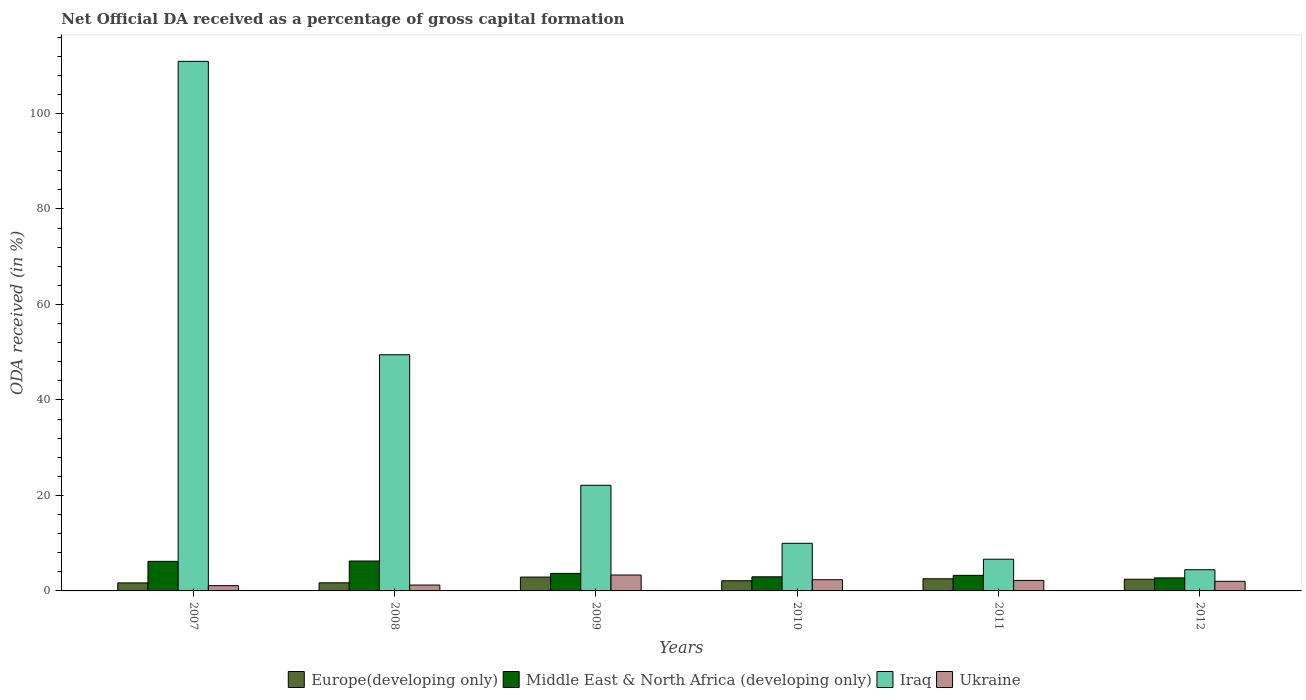How many groups of bars are there?
Provide a succinct answer. 6. Are the number of bars per tick equal to the number of legend labels?
Provide a short and direct response. Yes. Are the number of bars on each tick of the X-axis equal?
Give a very brief answer. Yes. How many bars are there on the 4th tick from the right?
Ensure brevity in your answer.  4. What is the net ODA received in Europe(developing only) in 2008?
Make the answer very short. 1.7. Across all years, what is the maximum net ODA received in Ukraine?
Ensure brevity in your answer.  3.33. Across all years, what is the minimum net ODA received in Ukraine?
Provide a short and direct response. 1.1. In which year was the net ODA received in Ukraine minimum?
Keep it short and to the point. 2007. What is the total net ODA received in Ukraine in the graph?
Your answer should be compact. 12.23. What is the difference between the net ODA received in Middle East & North Africa (developing only) in 2011 and that in 2012?
Your answer should be compact. 0.53. What is the difference between the net ODA received in Iraq in 2007 and the net ODA received in Europe(developing only) in 2009?
Offer a very short reply. 108.01. What is the average net ODA received in Iraq per year?
Offer a terse response. 33.92. In the year 2008, what is the difference between the net ODA received in Europe(developing only) and net ODA received in Iraq?
Your answer should be very brief. -47.76. In how many years, is the net ODA received in Ukraine greater than 112 %?
Provide a succinct answer. 0. What is the ratio of the net ODA received in Ukraine in 2007 to that in 2009?
Give a very brief answer. 0.33. Is the difference between the net ODA received in Europe(developing only) in 2008 and 2011 greater than the difference between the net ODA received in Iraq in 2008 and 2011?
Make the answer very short. No. What is the difference between the highest and the second highest net ODA received in Europe(developing only)?
Provide a succinct answer. 0.36. What is the difference between the highest and the lowest net ODA received in Iraq?
Offer a terse response. 106.47. Is it the case that in every year, the sum of the net ODA received in Middle East & North Africa (developing only) and net ODA received in Iraq is greater than the sum of net ODA received in Ukraine and net ODA received in Europe(developing only)?
Provide a short and direct response. No. What does the 2nd bar from the left in 2010 represents?
Give a very brief answer. Middle East & North Africa (developing only). What does the 2nd bar from the right in 2007 represents?
Your answer should be very brief. Iraq. How many bars are there?
Your answer should be compact. 24. Are all the bars in the graph horizontal?
Give a very brief answer. No. How many years are there in the graph?
Offer a very short reply. 6. Does the graph contain any zero values?
Make the answer very short. No. How many legend labels are there?
Ensure brevity in your answer.  4. What is the title of the graph?
Offer a terse response. Net Official DA received as a percentage of gross capital formation. What is the label or title of the X-axis?
Your answer should be compact. Years. What is the label or title of the Y-axis?
Offer a very short reply. ODA received (in %). What is the ODA received (in %) of Europe(developing only) in 2007?
Your answer should be very brief. 1.68. What is the ODA received (in %) of Middle East & North Africa (developing only) in 2007?
Provide a succinct answer. 6.2. What is the ODA received (in %) in Iraq in 2007?
Your response must be concise. 110.91. What is the ODA received (in %) in Ukraine in 2007?
Provide a short and direct response. 1.1. What is the ODA received (in %) of Europe(developing only) in 2008?
Your answer should be very brief. 1.7. What is the ODA received (in %) of Middle East & North Africa (developing only) in 2008?
Offer a very short reply. 6.26. What is the ODA received (in %) in Iraq in 2008?
Your answer should be compact. 49.46. What is the ODA received (in %) in Ukraine in 2008?
Your answer should be very brief. 1.23. What is the ODA received (in %) in Europe(developing only) in 2009?
Provide a short and direct response. 2.9. What is the ODA received (in %) of Middle East & North Africa (developing only) in 2009?
Keep it short and to the point. 3.67. What is the ODA received (in %) in Iraq in 2009?
Keep it short and to the point. 22.13. What is the ODA received (in %) of Ukraine in 2009?
Make the answer very short. 3.33. What is the ODA received (in %) in Europe(developing only) in 2010?
Keep it short and to the point. 2.13. What is the ODA received (in %) in Middle East & North Africa (developing only) in 2010?
Provide a succinct answer. 2.96. What is the ODA received (in %) of Iraq in 2010?
Offer a terse response. 9.97. What is the ODA received (in %) of Ukraine in 2010?
Your answer should be compact. 2.35. What is the ODA received (in %) of Europe(developing only) in 2011?
Ensure brevity in your answer.  2.54. What is the ODA received (in %) of Middle East & North Africa (developing only) in 2011?
Provide a succinct answer. 3.27. What is the ODA received (in %) in Iraq in 2011?
Offer a very short reply. 6.65. What is the ODA received (in %) of Ukraine in 2011?
Provide a short and direct response. 2.2. What is the ODA received (in %) of Europe(developing only) in 2012?
Your answer should be very brief. 2.45. What is the ODA received (in %) of Middle East & North Africa (developing only) in 2012?
Your answer should be very brief. 2.73. What is the ODA received (in %) in Iraq in 2012?
Offer a very short reply. 4.44. What is the ODA received (in %) in Ukraine in 2012?
Provide a succinct answer. 2.02. Across all years, what is the maximum ODA received (in %) in Europe(developing only)?
Your answer should be compact. 2.9. Across all years, what is the maximum ODA received (in %) of Middle East & North Africa (developing only)?
Your answer should be very brief. 6.26. Across all years, what is the maximum ODA received (in %) in Iraq?
Offer a terse response. 110.91. Across all years, what is the maximum ODA received (in %) of Ukraine?
Give a very brief answer. 3.33. Across all years, what is the minimum ODA received (in %) of Europe(developing only)?
Make the answer very short. 1.68. Across all years, what is the minimum ODA received (in %) of Middle East & North Africa (developing only)?
Provide a short and direct response. 2.73. Across all years, what is the minimum ODA received (in %) of Iraq?
Provide a succinct answer. 4.44. Across all years, what is the minimum ODA received (in %) in Ukraine?
Offer a very short reply. 1.1. What is the total ODA received (in %) of Europe(developing only) in the graph?
Your answer should be very brief. 13.4. What is the total ODA received (in %) of Middle East & North Africa (developing only) in the graph?
Your response must be concise. 25.08. What is the total ODA received (in %) of Iraq in the graph?
Your answer should be compact. 203.55. What is the total ODA received (in %) of Ukraine in the graph?
Your answer should be very brief. 12.23. What is the difference between the ODA received (in %) of Europe(developing only) in 2007 and that in 2008?
Offer a very short reply. -0.02. What is the difference between the ODA received (in %) of Middle East & North Africa (developing only) in 2007 and that in 2008?
Offer a very short reply. -0.07. What is the difference between the ODA received (in %) of Iraq in 2007 and that in 2008?
Give a very brief answer. 61.45. What is the difference between the ODA received (in %) of Ukraine in 2007 and that in 2008?
Your answer should be very brief. -0.12. What is the difference between the ODA received (in %) in Europe(developing only) in 2007 and that in 2009?
Ensure brevity in your answer.  -1.22. What is the difference between the ODA received (in %) of Middle East & North Africa (developing only) in 2007 and that in 2009?
Your answer should be very brief. 2.53. What is the difference between the ODA received (in %) of Iraq in 2007 and that in 2009?
Your response must be concise. 88.78. What is the difference between the ODA received (in %) of Ukraine in 2007 and that in 2009?
Your answer should be compact. -2.23. What is the difference between the ODA received (in %) of Europe(developing only) in 2007 and that in 2010?
Give a very brief answer. -0.45. What is the difference between the ODA received (in %) of Middle East & North Africa (developing only) in 2007 and that in 2010?
Make the answer very short. 3.24. What is the difference between the ODA received (in %) of Iraq in 2007 and that in 2010?
Offer a terse response. 100.94. What is the difference between the ODA received (in %) in Ukraine in 2007 and that in 2010?
Your response must be concise. -1.24. What is the difference between the ODA received (in %) of Europe(developing only) in 2007 and that in 2011?
Offer a terse response. -0.86. What is the difference between the ODA received (in %) of Middle East & North Africa (developing only) in 2007 and that in 2011?
Ensure brevity in your answer.  2.93. What is the difference between the ODA received (in %) in Iraq in 2007 and that in 2011?
Offer a terse response. 104.26. What is the difference between the ODA received (in %) of Ukraine in 2007 and that in 2011?
Your answer should be compact. -1.1. What is the difference between the ODA received (in %) of Europe(developing only) in 2007 and that in 2012?
Provide a succinct answer. -0.77. What is the difference between the ODA received (in %) in Middle East & North Africa (developing only) in 2007 and that in 2012?
Provide a short and direct response. 3.46. What is the difference between the ODA received (in %) of Iraq in 2007 and that in 2012?
Give a very brief answer. 106.47. What is the difference between the ODA received (in %) in Ukraine in 2007 and that in 2012?
Offer a terse response. -0.91. What is the difference between the ODA received (in %) in Europe(developing only) in 2008 and that in 2009?
Your answer should be very brief. -1.2. What is the difference between the ODA received (in %) in Middle East & North Africa (developing only) in 2008 and that in 2009?
Give a very brief answer. 2.6. What is the difference between the ODA received (in %) of Iraq in 2008 and that in 2009?
Give a very brief answer. 27.33. What is the difference between the ODA received (in %) in Ukraine in 2008 and that in 2009?
Ensure brevity in your answer.  -2.1. What is the difference between the ODA received (in %) in Europe(developing only) in 2008 and that in 2010?
Offer a terse response. -0.43. What is the difference between the ODA received (in %) in Middle East & North Africa (developing only) in 2008 and that in 2010?
Offer a very short reply. 3.31. What is the difference between the ODA received (in %) in Iraq in 2008 and that in 2010?
Provide a short and direct response. 39.49. What is the difference between the ODA received (in %) of Ukraine in 2008 and that in 2010?
Ensure brevity in your answer.  -1.12. What is the difference between the ODA received (in %) in Europe(developing only) in 2008 and that in 2011?
Ensure brevity in your answer.  -0.84. What is the difference between the ODA received (in %) of Middle East & North Africa (developing only) in 2008 and that in 2011?
Provide a short and direct response. 3. What is the difference between the ODA received (in %) of Iraq in 2008 and that in 2011?
Keep it short and to the point. 42.82. What is the difference between the ODA received (in %) in Ukraine in 2008 and that in 2011?
Give a very brief answer. -0.97. What is the difference between the ODA received (in %) in Europe(developing only) in 2008 and that in 2012?
Make the answer very short. -0.75. What is the difference between the ODA received (in %) in Middle East & North Africa (developing only) in 2008 and that in 2012?
Offer a terse response. 3.53. What is the difference between the ODA received (in %) of Iraq in 2008 and that in 2012?
Ensure brevity in your answer.  45.02. What is the difference between the ODA received (in %) in Ukraine in 2008 and that in 2012?
Your answer should be very brief. -0.79. What is the difference between the ODA received (in %) in Europe(developing only) in 2009 and that in 2010?
Your response must be concise. 0.77. What is the difference between the ODA received (in %) of Middle East & North Africa (developing only) in 2009 and that in 2010?
Your answer should be compact. 0.71. What is the difference between the ODA received (in %) in Iraq in 2009 and that in 2010?
Provide a short and direct response. 12.16. What is the difference between the ODA received (in %) in Ukraine in 2009 and that in 2010?
Make the answer very short. 0.98. What is the difference between the ODA received (in %) of Europe(developing only) in 2009 and that in 2011?
Provide a succinct answer. 0.36. What is the difference between the ODA received (in %) in Middle East & North Africa (developing only) in 2009 and that in 2011?
Offer a very short reply. 0.4. What is the difference between the ODA received (in %) in Iraq in 2009 and that in 2011?
Make the answer very short. 15.48. What is the difference between the ODA received (in %) in Ukraine in 2009 and that in 2011?
Your answer should be very brief. 1.13. What is the difference between the ODA received (in %) of Europe(developing only) in 2009 and that in 2012?
Your answer should be compact. 0.45. What is the difference between the ODA received (in %) of Middle East & North Africa (developing only) in 2009 and that in 2012?
Your answer should be very brief. 0.93. What is the difference between the ODA received (in %) in Iraq in 2009 and that in 2012?
Ensure brevity in your answer.  17.69. What is the difference between the ODA received (in %) of Ukraine in 2009 and that in 2012?
Offer a very short reply. 1.32. What is the difference between the ODA received (in %) of Europe(developing only) in 2010 and that in 2011?
Make the answer very short. -0.41. What is the difference between the ODA received (in %) in Middle East & North Africa (developing only) in 2010 and that in 2011?
Your answer should be very brief. -0.31. What is the difference between the ODA received (in %) in Iraq in 2010 and that in 2011?
Your answer should be compact. 3.33. What is the difference between the ODA received (in %) of Ukraine in 2010 and that in 2011?
Provide a succinct answer. 0.15. What is the difference between the ODA received (in %) of Europe(developing only) in 2010 and that in 2012?
Provide a succinct answer. -0.32. What is the difference between the ODA received (in %) of Middle East & North Africa (developing only) in 2010 and that in 2012?
Your response must be concise. 0.23. What is the difference between the ODA received (in %) of Iraq in 2010 and that in 2012?
Provide a short and direct response. 5.53. What is the difference between the ODA received (in %) of Ukraine in 2010 and that in 2012?
Ensure brevity in your answer.  0.33. What is the difference between the ODA received (in %) in Europe(developing only) in 2011 and that in 2012?
Your response must be concise. 0.09. What is the difference between the ODA received (in %) of Middle East & North Africa (developing only) in 2011 and that in 2012?
Offer a very short reply. 0.53. What is the difference between the ODA received (in %) of Iraq in 2011 and that in 2012?
Give a very brief answer. 2.21. What is the difference between the ODA received (in %) of Ukraine in 2011 and that in 2012?
Make the answer very short. 0.19. What is the difference between the ODA received (in %) in Europe(developing only) in 2007 and the ODA received (in %) in Middle East & North Africa (developing only) in 2008?
Give a very brief answer. -4.58. What is the difference between the ODA received (in %) of Europe(developing only) in 2007 and the ODA received (in %) of Iraq in 2008?
Provide a short and direct response. -47.78. What is the difference between the ODA received (in %) of Europe(developing only) in 2007 and the ODA received (in %) of Ukraine in 2008?
Offer a terse response. 0.45. What is the difference between the ODA received (in %) in Middle East & North Africa (developing only) in 2007 and the ODA received (in %) in Iraq in 2008?
Your answer should be compact. -43.27. What is the difference between the ODA received (in %) of Middle East & North Africa (developing only) in 2007 and the ODA received (in %) of Ukraine in 2008?
Ensure brevity in your answer.  4.97. What is the difference between the ODA received (in %) of Iraq in 2007 and the ODA received (in %) of Ukraine in 2008?
Offer a terse response. 109.68. What is the difference between the ODA received (in %) of Europe(developing only) in 2007 and the ODA received (in %) of Middle East & North Africa (developing only) in 2009?
Provide a succinct answer. -1.99. What is the difference between the ODA received (in %) of Europe(developing only) in 2007 and the ODA received (in %) of Iraq in 2009?
Offer a terse response. -20.45. What is the difference between the ODA received (in %) in Europe(developing only) in 2007 and the ODA received (in %) in Ukraine in 2009?
Your answer should be compact. -1.65. What is the difference between the ODA received (in %) of Middle East & North Africa (developing only) in 2007 and the ODA received (in %) of Iraq in 2009?
Make the answer very short. -15.93. What is the difference between the ODA received (in %) in Middle East & North Africa (developing only) in 2007 and the ODA received (in %) in Ukraine in 2009?
Provide a succinct answer. 2.86. What is the difference between the ODA received (in %) in Iraq in 2007 and the ODA received (in %) in Ukraine in 2009?
Make the answer very short. 107.58. What is the difference between the ODA received (in %) in Europe(developing only) in 2007 and the ODA received (in %) in Middle East & North Africa (developing only) in 2010?
Ensure brevity in your answer.  -1.28. What is the difference between the ODA received (in %) of Europe(developing only) in 2007 and the ODA received (in %) of Iraq in 2010?
Provide a succinct answer. -8.29. What is the difference between the ODA received (in %) of Europe(developing only) in 2007 and the ODA received (in %) of Ukraine in 2010?
Your answer should be very brief. -0.67. What is the difference between the ODA received (in %) of Middle East & North Africa (developing only) in 2007 and the ODA received (in %) of Iraq in 2010?
Keep it short and to the point. -3.78. What is the difference between the ODA received (in %) of Middle East & North Africa (developing only) in 2007 and the ODA received (in %) of Ukraine in 2010?
Your answer should be very brief. 3.85. What is the difference between the ODA received (in %) in Iraq in 2007 and the ODA received (in %) in Ukraine in 2010?
Your answer should be compact. 108.56. What is the difference between the ODA received (in %) in Europe(developing only) in 2007 and the ODA received (in %) in Middle East & North Africa (developing only) in 2011?
Ensure brevity in your answer.  -1.59. What is the difference between the ODA received (in %) of Europe(developing only) in 2007 and the ODA received (in %) of Iraq in 2011?
Your answer should be very brief. -4.97. What is the difference between the ODA received (in %) of Europe(developing only) in 2007 and the ODA received (in %) of Ukraine in 2011?
Offer a terse response. -0.52. What is the difference between the ODA received (in %) in Middle East & North Africa (developing only) in 2007 and the ODA received (in %) in Iraq in 2011?
Provide a short and direct response. -0.45. What is the difference between the ODA received (in %) of Middle East & North Africa (developing only) in 2007 and the ODA received (in %) of Ukraine in 2011?
Keep it short and to the point. 3.99. What is the difference between the ODA received (in %) in Iraq in 2007 and the ODA received (in %) in Ukraine in 2011?
Ensure brevity in your answer.  108.71. What is the difference between the ODA received (in %) of Europe(developing only) in 2007 and the ODA received (in %) of Middle East & North Africa (developing only) in 2012?
Provide a succinct answer. -1.05. What is the difference between the ODA received (in %) of Europe(developing only) in 2007 and the ODA received (in %) of Iraq in 2012?
Ensure brevity in your answer.  -2.76. What is the difference between the ODA received (in %) of Europe(developing only) in 2007 and the ODA received (in %) of Ukraine in 2012?
Provide a succinct answer. -0.34. What is the difference between the ODA received (in %) of Middle East & North Africa (developing only) in 2007 and the ODA received (in %) of Iraq in 2012?
Give a very brief answer. 1.76. What is the difference between the ODA received (in %) of Middle East & North Africa (developing only) in 2007 and the ODA received (in %) of Ukraine in 2012?
Your response must be concise. 4.18. What is the difference between the ODA received (in %) of Iraq in 2007 and the ODA received (in %) of Ukraine in 2012?
Make the answer very short. 108.89. What is the difference between the ODA received (in %) of Europe(developing only) in 2008 and the ODA received (in %) of Middle East & North Africa (developing only) in 2009?
Your response must be concise. -1.97. What is the difference between the ODA received (in %) in Europe(developing only) in 2008 and the ODA received (in %) in Iraq in 2009?
Provide a short and direct response. -20.43. What is the difference between the ODA received (in %) in Europe(developing only) in 2008 and the ODA received (in %) in Ukraine in 2009?
Offer a terse response. -1.63. What is the difference between the ODA received (in %) of Middle East & North Africa (developing only) in 2008 and the ODA received (in %) of Iraq in 2009?
Your answer should be very brief. -15.86. What is the difference between the ODA received (in %) in Middle East & North Africa (developing only) in 2008 and the ODA received (in %) in Ukraine in 2009?
Offer a very short reply. 2.93. What is the difference between the ODA received (in %) of Iraq in 2008 and the ODA received (in %) of Ukraine in 2009?
Ensure brevity in your answer.  46.13. What is the difference between the ODA received (in %) of Europe(developing only) in 2008 and the ODA received (in %) of Middle East & North Africa (developing only) in 2010?
Offer a very short reply. -1.26. What is the difference between the ODA received (in %) of Europe(developing only) in 2008 and the ODA received (in %) of Iraq in 2010?
Offer a very short reply. -8.27. What is the difference between the ODA received (in %) of Europe(developing only) in 2008 and the ODA received (in %) of Ukraine in 2010?
Keep it short and to the point. -0.65. What is the difference between the ODA received (in %) in Middle East & North Africa (developing only) in 2008 and the ODA received (in %) in Iraq in 2010?
Your answer should be very brief. -3.71. What is the difference between the ODA received (in %) in Middle East & North Africa (developing only) in 2008 and the ODA received (in %) in Ukraine in 2010?
Provide a short and direct response. 3.92. What is the difference between the ODA received (in %) of Iraq in 2008 and the ODA received (in %) of Ukraine in 2010?
Give a very brief answer. 47.11. What is the difference between the ODA received (in %) of Europe(developing only) in 2008 and the ODA received (in %) of Middle East & North Africa (developing only) in 2011?
Provide a short and direct response. -1.57. What is the difference between the ODA received (in %) of Europe(developing only) in 2008 and the ODA received (in %) of Iraq in 2011?
Ensure brevity in your answer.  -4.95. What is the difference between the ODA received (in %) in Europe(developing only) in 2008 and the ODA received (in %) in Ukraine in 2011?
Provide a succinct answer. -0.5. What is the difference between the ODA received (in %) in Middle East & North Africa (developing only) in 2008 and the ODA received (in %) in Iraq in 2011?
Your answer should be very brief. -0.38. What is the difference between the ODA received (in %) in Middle East & North Africa (developing only) in 2008 and the ODA received (in %) in Ukraine in 2011?
Provide a short and direct response. 4.06. What is the difference between the ODA received (in %) of Iraq in 2008 and the ODA received (in %) of Ukraine in 2011?
Give a very brief answer. 47.26. What is the difference between the ODA received (in %) of Europe(developing only) in 2008 and the ODA received (in %) of Middle East & North Africa (developing only) in 2012?
Offer a terse response. -1.03. What is the difference between the ODA received (in %) in Europe(developing only) in 2008 and the ODA received (in %) in Iraq in 2012?
Provide a short and direct response. -2.74. What is the difference between the ODA received (in %) in Europe(developing only) in 2008 and the ODA received (in %) in Ukraine in 2012?
Offer a very short reply. -0.32. What is the difference between the ODA received (in %) in Middle East & North Africa (developing only) in 2008 and the ODA received (in %) in Iraq in 2012?
Your answer should be compact. 1.83. What is the difference between the ODA received (in %) in Middle East & North Africa (developing only) in 2008 and the ODA received (in %) in Ukraine in 2012?
Give a very brief answer. 4.25. What is the difference between the ODA received (in %) of Iraq in 2008 and the ODA received (in %) of Ukraine in 2012?
Ensure brevity in your answer.  47.45. What is the difference between the ODA received (in %) of Europe(developing only) in 2009 and the ODA received (in %) of Middle East & North Africa (developing only) in 2010?
Your response must be concise. -0.06. What is the difference between the ODA received (in %) of Europe(developing only) in 2009 and the ODA received (in %) of Iraq in 2010?
Make the answer very short. -7.07. What is the difference between the ODA received (in %) in Europe(developing only) in 2009 and the ODA received (in %) in Ukraine in 2010?
Your response must be concise. 0.55. What is the difference between the ODA received (in %) of Middle East & North Africa (developing only) in 2009 and the ODA received (in %) of Iraq in 2010?
Your answer should be compact. -6.31. What is the difference between the ODA received (in %) of Middle East & North Africa (developing only) in 2009 and the ODA received (in %) of Ukraine in 2010?
Ensure brevity in your answer.  1.32. What is the difference between the ODA received (in %) of Iraq in 2009 and the ODA received (in %) of Ukraine in 2010?
Ensure brevity in your answer.  19.78. What is the difference between the ODA received (in %) of Europe(developing only) in 2009 and the ODA received (in %) of Middle East & North Africa (developing only) in 2011?
Your answer should be very brief. -0.37. What is the difference between the ODA received (in %) of Europe(developing only) in 2009 and the ODA received (in %) of Iraq in 2011?
Offer a very short reply. -3.75. What is the difference between the ODA received (in %) in Europe(developing only) in 2009 and the ODA received (in %) in Ukraine in 2011?
Keep it short and to the point. 0.7. What is the difference between the ODA received (in %) of Middle East & North Africa (developing only) in 2009 and the ODA received (in %) of Iraq in 2011?
Ensure brevity in your answer.  -2.98. What is the difference between the ODA received (in %) of Middle East & North Africa (developing only) in 2009 and the ODA received (in %) of Ukraine in 2011?
Give a very brief answer. 1.46. What is the difference between the ODA received (in %) of Iraq in 2009 and the ODA received (in %) of Ukraine in 2011?
Make the answer very short. 19.93. What is the difference between the ODA received (in %) in Europe(developing only) in 2009 and the ODA received (in %) in Middle East & North Africa (developing only) in 2012?
Your response must be concise. 0.17. What is the difference between the ODA received (in %) of Europe(developing only) in 2009 and the ODA received (in %) of Iraq in 2012?
Your answer should be compact. -1.54. What is the difference between the ODA received (in %) in Europe(developing only) in 2009 and the ODA received (in %) in Ukraine in 2012?
Provide a short and direct response. 0.88. What is the difference between the ODA received (in %) of Middle East & North Africa (developing only) in 2009 and the ODA received (in %) of Iraq in 2012?
Give a very brief answer. -0.77. What is the difference between the ODA received (in %) in Middle East & North Africa (developing only) in 2009 and the ODA received (in %) in Ukraine in 2012?
Offer a very short reply. 1.65. What is the difference between the ODA received (in %) in Iraq in 2009 and the ODA received (in %) in Ukraine in 2012?
Provide a succinct answer. 20.11. What is the difference between the ODA received (in %) of Europe(developing only) in 2010 and the ODA received (in %) of Middle East & North Africa (developing only) in 2011?
Ensure brevity in your answer.  -1.13. What is the difference between the ODA received (in %) in Europe(developing only) in 2010 and the ODA received (in %) in Iraq in 2011?
Offer a very short reply. -4.51. What is the difference between the ODA received (in %) in Europe(developing only) in 2010 and the ODA received (in %) in Ukraine in 2011?
Offer a very short reply. -0.07. What is the difference between the ODA received (in %) in Middle East & North Africa (developing only) in 2010 and the ODA received (in %) in Iraq in 2011?
Provide a succinct answer. -3.69. What is the difference between the ODA received (in %) in Middle East & North Africa (developing only) in 2010 and the ODA received (in %) in Ukraine in 2011?
Keep it short and to the point. 0.76. What is the difference between the ODA received (in %) of Iraq in 2010 and the ODA received (in %) of Ukraine in 2011?
Ensure brevity in your answer.  7.77. What is the difference between the ODA received (in %) of Europe(developing only) in 2010 and the ODA received (in %) of Middle East & North Africa (developing only) in 2012?
Give a very brief answer. -0.6. What is the difference between the ODA received (in %) in Europe(developing only) in 2010 and the ODA received (in %) in Iraq in 2012?
Provide a short and direct response. -2.31. What is the difference between the ODA received (in %) in Europe(developing only) in 2010 and the ODA received (in %) in Ukraine in 2012?
Ensure brevity in your answer.  0.12. What is the difference between the ODA received (in %) of Middle East & North Africa (developing only) in 2010 and the ODA received (in %) of Iraq in 2012?
Provide a succinct answer. -1.48. What is the difference between the ODA received (in %) of Middle East & North Africa (developing only) in 2010 and the ODA received (in %) of Ukraine in 2012?
Your response must be concise. 0.94. What is the difference between the ODA received (in %) of Iraq in 2010 and the ODA received (in %) of Ukraine in 2012?
Ensure brevity in your answer.  7.96. What is the difference between the ODA received (in %) in Europe(developing only) in 2011 and the ODA received (in %) in Middle East & North Africa (developing only) in 2012?
Ensure brevity in your answer.  -0.19. What is the difference between the ODA received (in %) in Europe(developing only) in 2011 and the ODA received (in %) in Iraq in 2012?
Keep it short and to the point. -1.9. What is the difference between the ODA received (in %) of Europe(developing only) in 2011 and the ODA received (in %) of Ukraine in 2012?
Offer a very short reply. 0.53. What is the difference between the ODA received (in %) in Middle East & North Africa (developing only) in 2011 and the ODA received (in %) in Iraq in 2012?
Offer a terse response. -1.17. What is the difference between the ODA received (in %) in Middle East & North Africa (developing only) in 2011 and the ODA received (in %) in Ukraine in 2012?
Your response must be concise. 1.25. What is the difference between the ODA received (in %) in Iraq in 2011 and the ODA received (in %) in Ukraine in 2012?
Provide a succinct answer. 4.63. What is the average ODA received (in %) of Europe(developing only) per year?
Make the answer very short. 2.23. What is the average ODA received (in %) in Middle East & North Africa (developing only) per year?
Provide a succinct answer. 4.18. What is the average ODA received (in %) in Iraq per year?
Give a very brief answer. 33.92. What is the average ODA received (in %) in Ukraine per year?
Ensure brevity in your answer.  2.04. In the year 2007, what is the difference between the ODA received (in %) of Europe(developing only) and ODA received (in %) of Middle East & North Africa (developing only)?
Your answer should be very brief. -4.52. In the year 2007, what is the difference between the ODA received (in %) of Europe(developing only) and ODA received (in %) of Iraq?
Your answer should be very brief. -109.23. In the year 2007, what is the difference between the ODA received (in %) in Europe(developing only) and ODA received (in %) in Ukraine?
Ensure brevity in your answer.  0.57. In the year 2007, what is the difference between the ODA received (in %) of Middle East & North Africa (developing only) and ODA received (in %) of Iraq?
Ensure brevity in your answer.  -104.71. In the year 2007, what is the difference between the ODA received (in %) of Middle East & North Africa (developing only) and ODA received (in %) of Ukraine?
Make the answer very short. 5.09. In the year 2007, what is the difference between the ODA received (in %) of Iraq and ODA received (in %) of Ukraine?
Your response must be concise. 109.8. In the year 2008, what is the difference between the ODA received (in %) in Europe(developing only) and ODA received (in %) in Middle East & North Africa (developing only)?
Your answer should be compact. -4.56. In the year 2008, what is the difference between the ODA received (in %) in Europe(developing only) and ODA received (in %) in Iraq?
Offer a terse response. -47.76. In the year 2008, what is the difference between the ODA received (in %) in Europe(developing only) and ODA received (in %) in Ukraine?
Your response must be concise. 0.47. In the year 2008, what is the difference between the ODA received (in %) of Middle East & North Africa (developing only) and ODA received (in %) of Iraq?
Your response must be concise. -43.2. In the year 2008, what is the difference between the ODA received (in %) of Middle East & North Africa (developing only) and ODA received (in %) of Ukraine?
Make the answer very short. 5.03. In the year 2008, what is the difference between the ODA received (in %) in Iraq and ODA received (in %) in Ukraine?
Make the answer very short. 48.23. In the year 2009, what is the difference between the ODA received (in %) in Europe(developing only) and ODA received (in %) in Middle East & North Africa (developing only)?
Your answer should be very brief. -0.77. In the year 2009, what is the difference between the ODA received (in %) of Europe(developing only) and ODA received (in %) of Iraq?
Your answer should be compact. -19.23. In the year 2009, what is the difference between the ODA received (in %) of Europe(developing only) and ODA received (in %) of Ukraine?
Your response must be concise. -0.43. In the year 2009, what is the difference between the ODA received (in %) in Middle East & North Africa (developing only) and ODA received (in %) in Iraq?
Your answer should be compact. -18.46. In the year 2009, what is the difference between the ODA received (in %) of Middle East & North Africa (developing only) and ODA received (in %) of Ukraine?
Ensure brevity in your answer.  0.33. In the year 2009, what is the difference between the ODA received (in %) in Iraq and ODA received (in %) in Ukraine?
Provide a short and direct response. 18.8. In the year 2010, what is the difference between the ODA received (in %) in Europe(developing only) and ODA received (in %) in Middle East & North Africa (developing only)?
Your answer should be compact. -0.83. In the year 2010, what is the difference between the ODA received (in %) of Europe(developing only) and ODA received (in %) of Iraq?
Your answer should be compact. -7.84. In the year 2010, what is the difference between the ODA received (in %) in Europe(developing only) and ODA received (in %) in Ukraine?
Provide a short and direct response. -0.22. In the year 2010, what is the difference between the ODA received (in %) of Middle East & North Africa (developing only) and ODA received (in %) of Iraq?
Offer a terse response. -7.01. In the year 2010, what is the difference between the ODA received (in %) of Middle East & North Africa (developing only) and ODA received (in %) of Ukraine?
Make the answer very short. 0.61. In the year 2010, what is the difference between the ODA received (in %) of Iraq and ODA received (in %) of Ukraine?
Give a very brief answer. 7.62. In the year 2011, what is the difference between the ODA received (in %) of Europe(developing only) and ODA received (in %) of Middle East & North Africa (developing only)?
Make the answer very short. -0.72. In the year 2011, what is the difference between the ODA received (in %) in Europe(developing only) and ODA received (in %) in Iraq?
Your response must be concise. -4.1. In the year 2011, what is the difference between the ODA received (in %) in Europe(developing only) and ODA received (in %) in Ukraine?
Make the answer very short. 0.34. In the year 2011, what is the difference between the ODA received (in %) in Middle East & North Africa (developing only) and ODA received (in %) in Iraq?
Ensure brevity in your answer.  -3.38. In the year 2011, what is the difference between the ODA received (in %) of Middle East & North Africa (developing only) and ODA received (in %) of Ukraine?
Make the answer very short. 1.06. In the year 2011, what is the difference between the ODA received (in %) of Iraq and ODA received (in %) of Ukraine?
Your answer should be compact. 4.44. In the year 2012, what is the difference between the ODA received (in %) of Europe(developing only) and ODA received (in %) of Middle East & North Africa (developing only)?
Ensure brevity in your answer.  -0.28. In the year 2012, what is the difference between the ODA received (in %) of Europe(developing only) and ODA received (in %) of Iraq?
Provide a short and direct response. -1.99. In the year 2012, what is the difference between the ODA received (in %) of Europe(developing only) and ODA received (in %) of Ukraine?
Your response must be concise. 0.43. In the year 2012, what is the difference between the ODA received (in %) in Middle East & North Africa (developing only) and ODA received (in %) in Iraq?
Make the answer very short. -1.71. In the year 2012, what is the difference between the ODA received (in %) in Middle East & North Africa (developing only) and ODA received (in %) in Ukraine?
Offer a terse response. 0.72. In the year 2012, what is the difference between the ODA received (in %) in Iraq and ODA received (in %) in Ukraine?
Keep it short and to the point. 2.42. What is the ratio of the ODA received (in %) of Europe(developing only) in 2007 to that in 2008?
Your answer should be very brief. 0.99. What is the ratio of the ODA received (in %) of Middle East & North Africa (developing only) in 2007 to that in 2008?
Make the answer very short. 0.99. What is the ratio of the ODA received (in %) in Iraq in 2007 to that in 2008?
Your answer should be compact. 2.24. What is the ratio of the ODA received (in %) of Ukraine in 2007 to that in 2008?
Make the answer very short. 0.9. What is the ratio of the ODA received (in %) of Europe(developing only) in 2007 to that in 2009?
Give a very brief answer. 0.58. What is the ratio of the ODA received (in %) in Middle East & North Africa (developing only) in 2007 to that in 2009?
Give a very brief answer. 1.69. What is the ratio of the ODA received (in %) of Iraq in 2007 to that in 2009?
Make the answer very short. 5.01. What is the ratio of the ODA received (in %) in Ukraine in 2007 to that in 2009?
Give a very brief answer. 0.33. What is the ratio of the ODA received (in %) in Europe(developing only) in 2007 to that in 2010?
Offer a terse response. 0.79. What is the ratio of the ODA received (in %) in Middle East & North Africa (developing only) in 2007 to that in 2010?
Offer a terse response. 2.1. What is the ratio of the ODA received (in %) in Iraq in 2007 to that in 2010?
Your answer should be compact. 11.12. What is the ratio of the ODA received (in %) in Ukraine in 2007 to that in 2010?
Offer a terse response. 0.47. What is the ratio of the ODA received (in %) of Europe(developing only) in 2007 to that in 2011?
Give a very brief answer. 0.66. What is the ratio of the ODA received (in %) of Middle East & North Africa (developing only) in 2007 to that in 2011?
Your answer should be compact. 1.9. What is the ratio of the ODA received (in %) in Iraq in 2007 to that in 2011?
Give a very brief answer. 16.69. What is the ratio of the ODA received (in %) of Ukraine in 2007 to that in 2011?
Make the answer very short. 0.5. What is the ratio of the ODA received (in %) of Europe(developing only) in 2007 to that in 2012?
Ensure brevity in your answer.  0.69. What is the ratio of the ODA received (in %) in Middle East & North Africa (developing only) in 2007 to that in 2012?
Provide a short and direct response. 2.27. What is the ratio of the ODA received (in %) in Iraq in 2007 to that in 2012?
Your answer should be compact. 24.99. What is the ratio of the ODA received (in %) in Ukraine in 2007 to that in 2012?
Provide a short and direct response. 0.55. What is the ratio of the ODA received (in %) of Europe(developing only) in 2008 to that in 2009?
Your answer should be very brief. 0.59. What is the ratio of the ODA received (in %) in Middle East & North Africa (developing only) in 2008 to that in 2009?
Your answer should be very brief. 1.71. What is the ratio of the ODA received (in %) in Iraq in 2008 to that in 2009?
Ensure brevity in your answer.  2.24. What is the ratio of the ODA received (in %) of Ukraine in 2008 to that in 2009?
Your answer should be compact. 0.37. What is the ratio of the ODA received (in %) of Europe(developing only) in 2008 to that in 2010?
Keep it short and to the point. 0.8. What is the ratio of the ODA received (in %) in Middle East & North Africa (developing only) in 2008 to that in 2010?
Give a very brief answer. 2.12. What is the ratio of the ODA received (in %) in Iraq in 2008 to that in 2010?
Give a very brief answer. 4.96. What is the ratio of the ODA received (in %) of Ukraine in 2008 to that in 2010?
Provide a short and direct response. 0.52. What is the ratio of the ODA received (in %) of Europe(developing only) in 2008 to that in 2011?
Your answer should be compact. 0.67. What is the ratio of the ODA received (in %) of Middle East & North Africa (developing only) in 2008 to that in 2011?
Your answer should be compact. 1.92. What is the ratio of the ODA received (in %) of Iraq in 2008 to that in 2011?
Offer a terse response. 7.44. What is the ratio of the ODA received (in %) in Ukraine in 2008 to that in 2011?
Your answer should be compact. 0.56. What is the ratio of the ODA received (in %) in Europe(developing only) in 2008 to that in 2012?
Make the answer very short. 0.69. What is the ratio of the ODA received (in %) in Middle East & North Africa (developing only) in 2008 to that in 2012?
Your response must be concise. 2.29. What is the ratio of the ODA received (in %) of Iraq in 2008 to that in 2012?
Keep it short and to the point. 11.14. What is the ratio of the ODA received (in %) of Ukraine in 2008 to that in 2012?
Your response must be concise. 0.61. What is the ratio of the ODA received (in %) in Europe(developing only) in 2009 to that in 2010?
Offer a terse response. 1.36. What is the ratio of the ODA received (in %) in Middle East & North Africa (developing only) in 2009 to that in 2010?
Keep it short and to the point. 1.24. What is the ratio of the ODA received (in %) in Iraq in 2009 to that in 2010?
Provide a short and direct response. 2.22. What is the ratio of the ODA received (in %) in Ukraine in 2009 to that in 2010?
Make the answer very short. 1.42. What is the ratio of the ODA received (in %) of Europe(developing only) in 2009 to that in 2011?
Your response must be concise. 1.14. What is the ratio of the ODA received (in %) in Middle East & North Africa (developing only) in 2009 to that in 2011?
Your response must be concise. 1.12. What is the ratio of the ODA received (in %) in Iraq in 2009 to that in 2011?
Your answer should be very brief. 3.33. What is the ratio of the ODA received (in %) in Ukraine in 2009 to that in 2011?
Provide a short and direct response. 1.51. What is the ratio of the ODA received (in %) of Europe(developing only) in 2009 to that in 2012?
Provide a short and direct response. 1.18. What is the ratio of the ODA received (in %) in Middle East & North Africa (developing only) in 2009 to that in 2012?
Offer a very short reply. 1.34. What is the ratio of the ODA received (in %) of Iraq in 2009 to that in 2012?
Your response must be concise. 4.99. What is the ratio of the ODA received (in %) of Ukraine in 2009 to that in 2012?
Ensure brevity in your answer.  1.65. What is the ratio of the ODA received (in %) in Europe(developing only) in 2010 to that in 2011?
Provide a succinct answer. 0.84. What is the ratio of the ODA received (in %) in Middle East & North Africa (developing only) in 2010 to that in 2011?
Your answer should be very brief. 0.91. What is the ratio of the ODA received (in %) in Iraq in 2010 to that in 2011?
Your answer should be very brief. 1.5. What is the ratio of the ODA received (in %) of Ukraine in 2010 to that in 2011?
Provide a succinct answer. 1.07. What is the ratio of the ODA received (in %) of Europe(developing only) in 2010 to that in 2012?
Your response must be concise. 0.87. What is the ratio of the ODA received (in %) of Middle East & North Africa (developing only) in 2010 to that in 2012?
Offer a terse response. 1.08. What is the ratio of the ODA received (in %) in Iraq in 2010 to that in 2012?
Give a very brief answer. 2.25. What is the ratio of the ODA received (in %) in Ukraine in 2010 to that in 2012?
Offer a very short reply. 1.16. What is the ratio of the ODA received (in %) of Europe(developing only) in 2011 to that in 2012?
Keep it short and to the point. 1.04. What is the ratio of the ODA received (in %) of Middle East & North Africa (developing only) in 2011 to that in 2012?
Give a very brief answer. 1.2. What is the ratio of the ODA received (in %) of Iraq in 2011 to that in 2012?
Make the answer very short. 1.5. What is the ratio of the ODA received (in %) in Ukraine in 2011 to that in 2012?
Offer a terse response. 1.09. What is the difference between the highest and the second highest ODA received (in %) of Europe(developing only)?
Offer a terse response. 0.36. What is the difference between the highest and the second highest ODA received (in %) in Middle East & North Africa (developing only)?
Your answer should be compact. 0.07. What is the difference between the highest and the second highest ODA received (in %) in Iraq?
Your answer should be very brief. 61.45. What is the difference between the highest and the second highest ODA received (in %) in Ukraine?
Ensure brevity in your answer.  0.98. What is the difference between the highest and the lowest ODA received (in %) of Europe(developing only)?
Your answer should be very brief. 1.22. What is the difference between the highest and the lowest ODA received (in %) of Middle East & North Africa (developing only)?
Your answer should be compact. 3.53. What is the difference between the highest and the lowest ODA received (in %) in Iraq?
Your answer should be compact. 106.47. What is the difference between the highest and the lowest ODA received (in %) in Ukraine?
Make the answer very short. 2.23. 